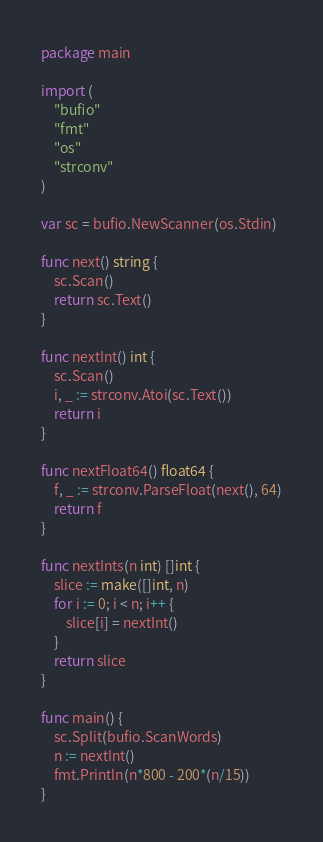<code> <loc_0><loc_0><loc_500><loc_500><_Go_>package main

import (
	"bufio"
	"fmt"
	"os"
	"strconv"
)

var sc = bufio.NewScanner(os.Stdin)

func next() string {
	sc.Scan()
	return sc.Text()
}

func nextInt() int {
	sc.Scan()
	i, _ := strconv.Atoi(sc.Text())
	return i
}

func nextFloat64() float64 {
	f, _ := strconv.ParseFloat(next(), 64)
	return f
}

func nextInts(n int) []int {
	slice := make([]int, n)
	for i := 0; i < n; i++ {
		slice[i] = nextInt()
	}
	return slice
}

func main() {
	sc.Split(bufio.ScanWords)
	n := nextInt()
	fmt.Println(n*800 - 200*(n/15))
}
</code> 